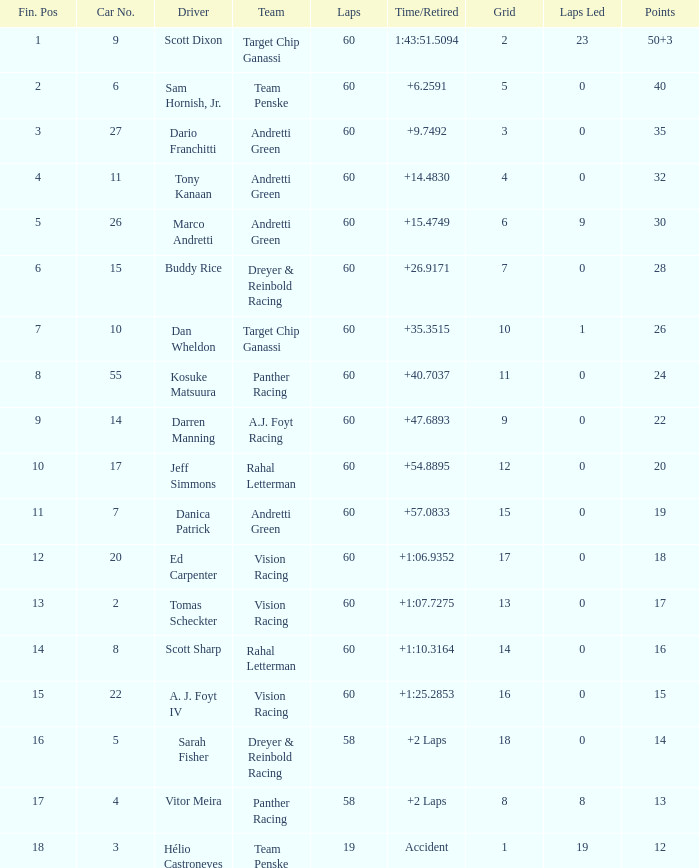Identify the motivation for points totaling 1 Vitor Meira. 